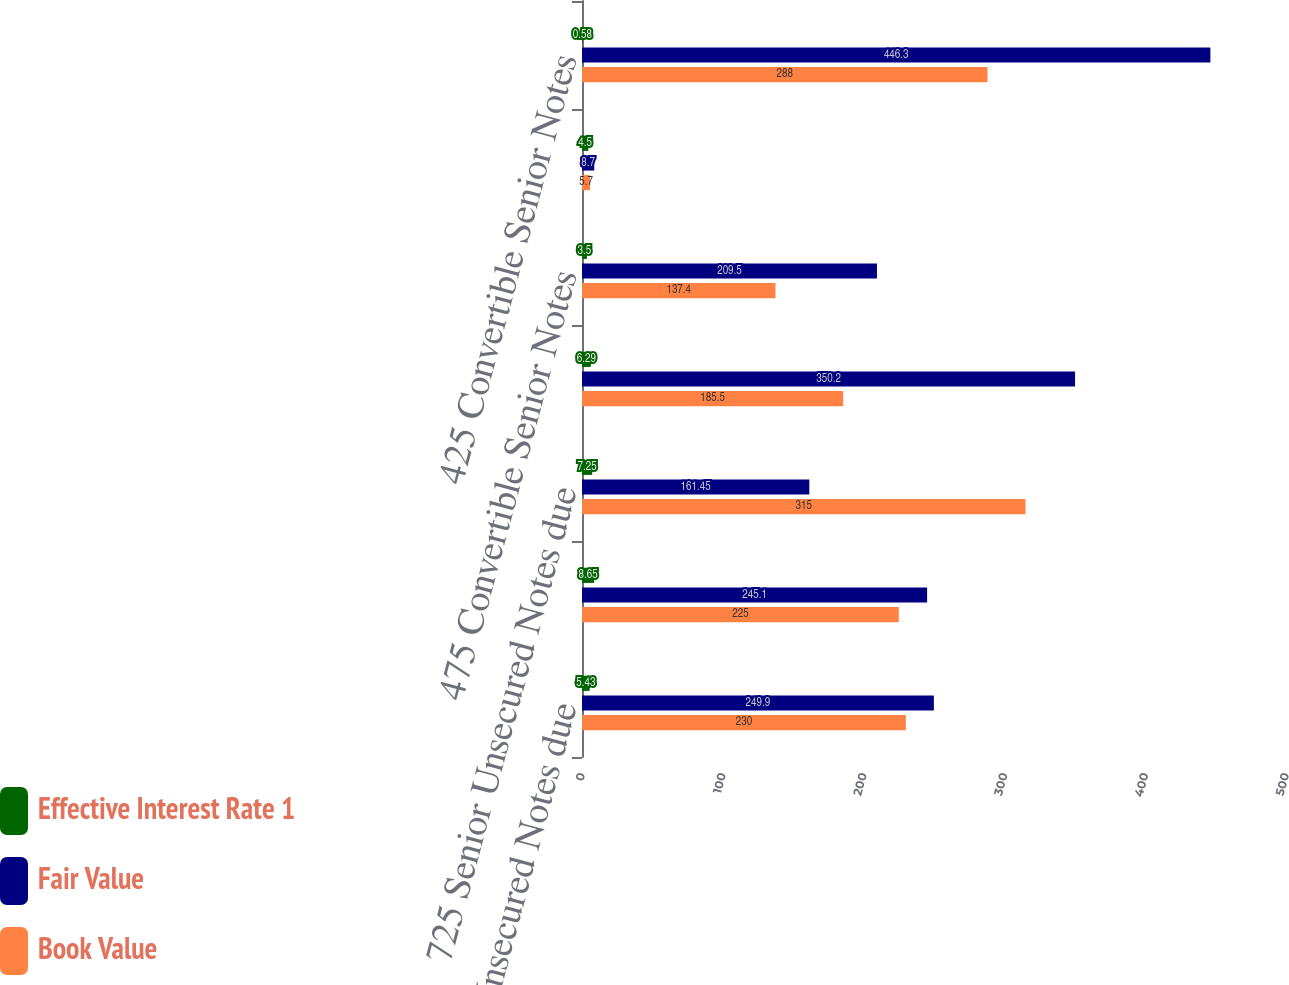<chart> <loc_0><loc_0><loc_500><loc_500><stacked_bar_chart><ecel><fcel>540 Senior Unsecured Notes due<fcel>Floating Rate Senior Unsecured<fcel>725 Senior Unsecured Notes due<fcel>625 Senior Unsecured Notes due<fcel>475 Convertible Senior Notes<fcel>450 Convertible Senior Notes<fcel>425 Convertible Senior Notes<nl><fcel>Effective Interest Rate 1<fcel>5.43<fcel>8.65<fcel>7.25<fcel>6.29<fcel>3.5<fcel>4.5<fcel>0.58<nl><fcel>Fair Value<fcel>249.9<fcel>245.1<fcel>161.45<fcel>350.2<fcel>209.5<fcel>8.7<fcel>446.3<nl><fcel>Book Value<fcel>230<fcel>225<fcel>315<fcel>185.5<fcel>137.4<fcel>5.7<fcel>288<nl></chart> 